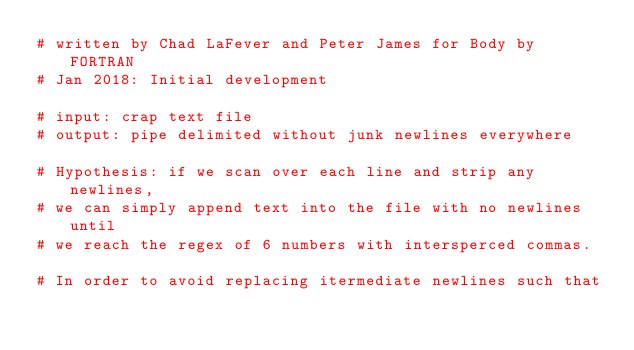Convert code to text. <code><loc_0><loc_0><loc_500><loc_500><_Python_># written by Chad LaFever and Peter James for Body by FORTRAN 
# Jan 2018: Initial development

# input: crap text file
# output: pipe delimited without junk newlines everywhere

# Hypothesis: if we scan over each line and strip any newlines, 
# we can simply append text into the file with no newlines until
# we reach the regex of 6 numbers with intersperced commas.

# In order to avoid replacing itermediate newlines such that </code> 